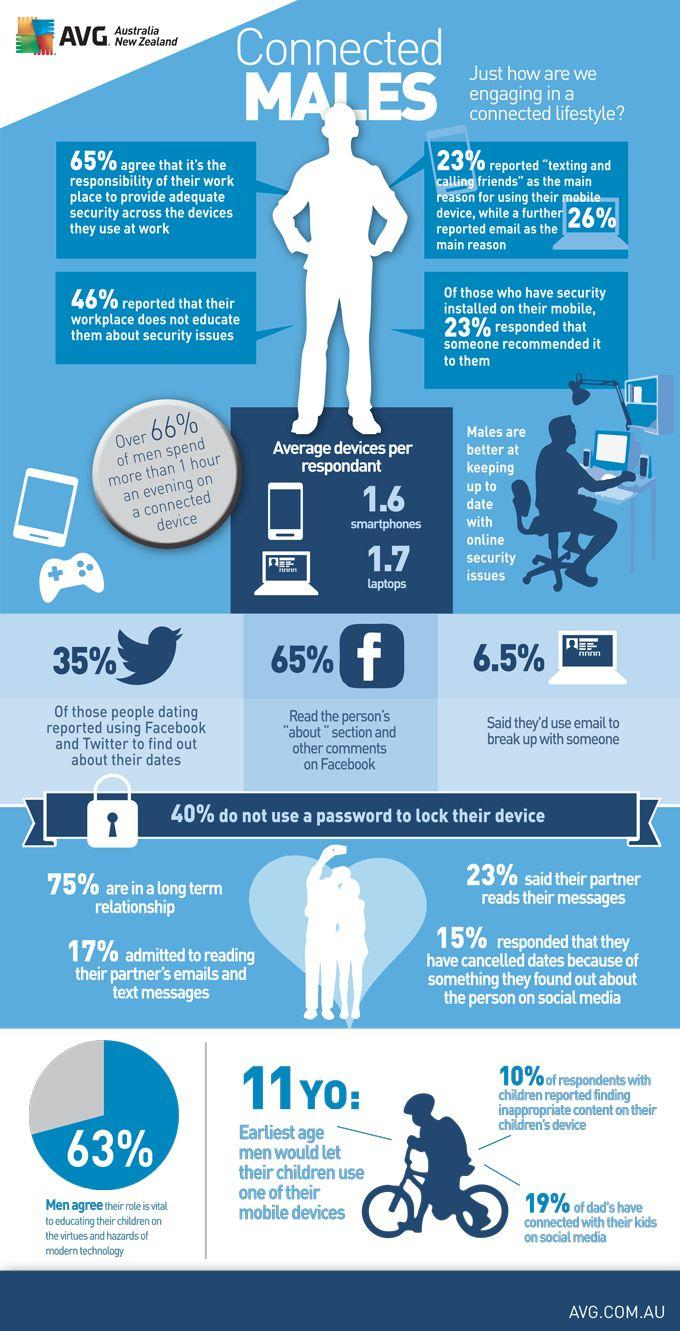Draw attention to some important aspects in this diagram. According to the survey, 54% of respondents reported that their workplace educates them about security issues. It is estimated that 25% of males are not currently in a long-term relationship. According to recent data, an overwhelming 81% of fathers have not connected with their children on social media. According to a survey, only 6.5% of people use email to break up with their significant others. 